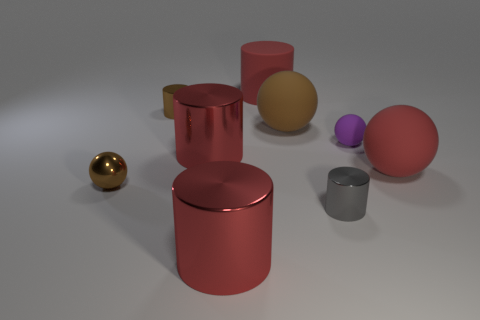What could be the material of these objects based on their appearance? The objects appear to have metallic finishes, suggesting they could be made of materials like metal or plastic with a metallic coating. The reflections and sheen on each object give away their likely smooth and solid texture. 